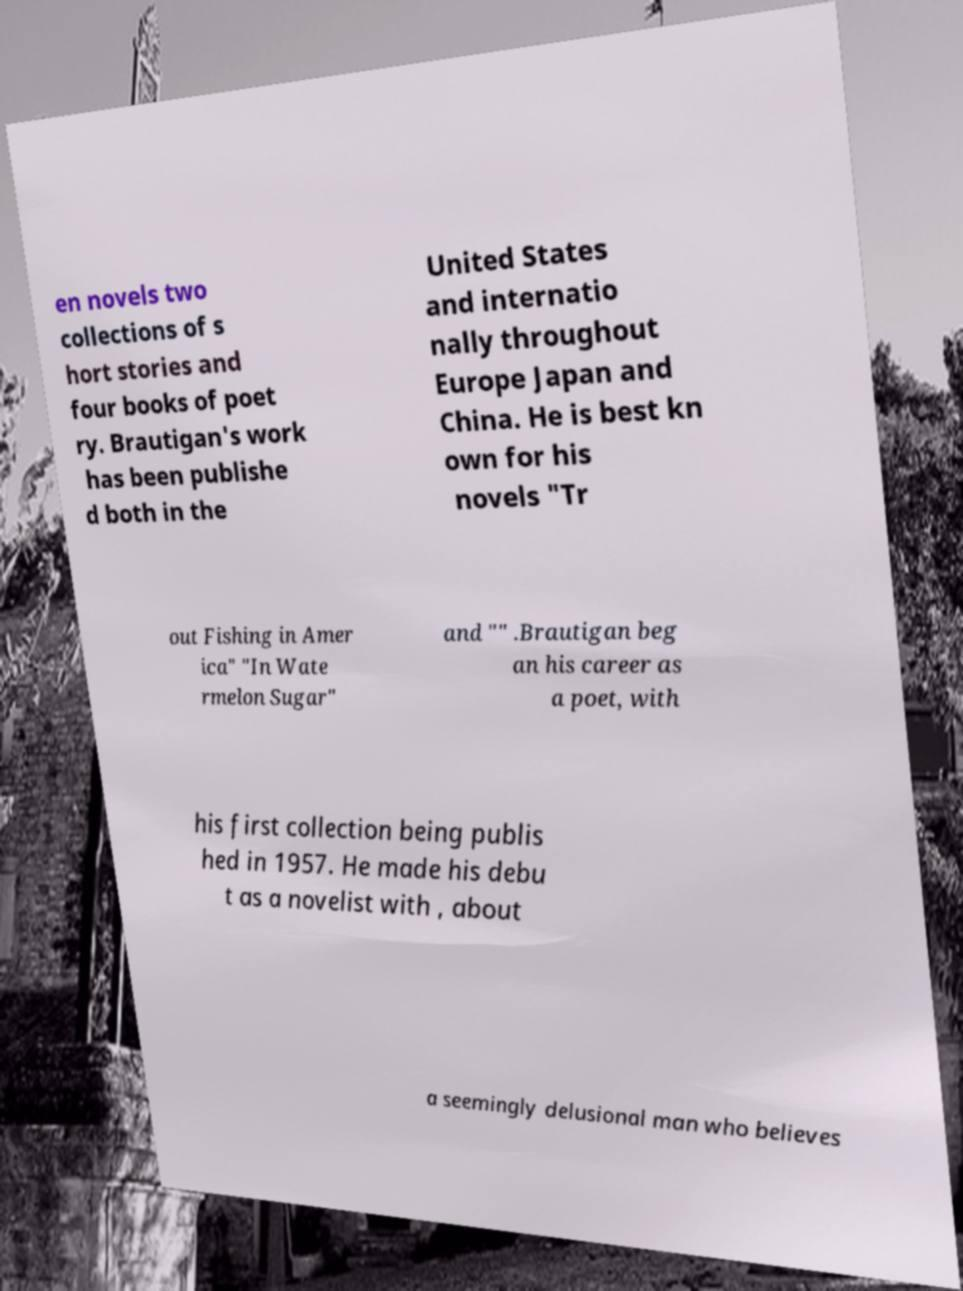I need the written content from this picture converted into text. Can you do that? en novels two collections of s hort stories and four books of poet ry. Brautigan's work has been publishe d both in the United States and internatio nally throughout Europe Japan and China. He is best kn own for his novels "Tr out Fishing in Amer ica" "In Wate rmelon Sugar" and "" .Brautigan beg an his career as a poet, with his first collection being publis hed in 1957. He made his debu t as a novelist with , about a seemingly delusional man who believes 